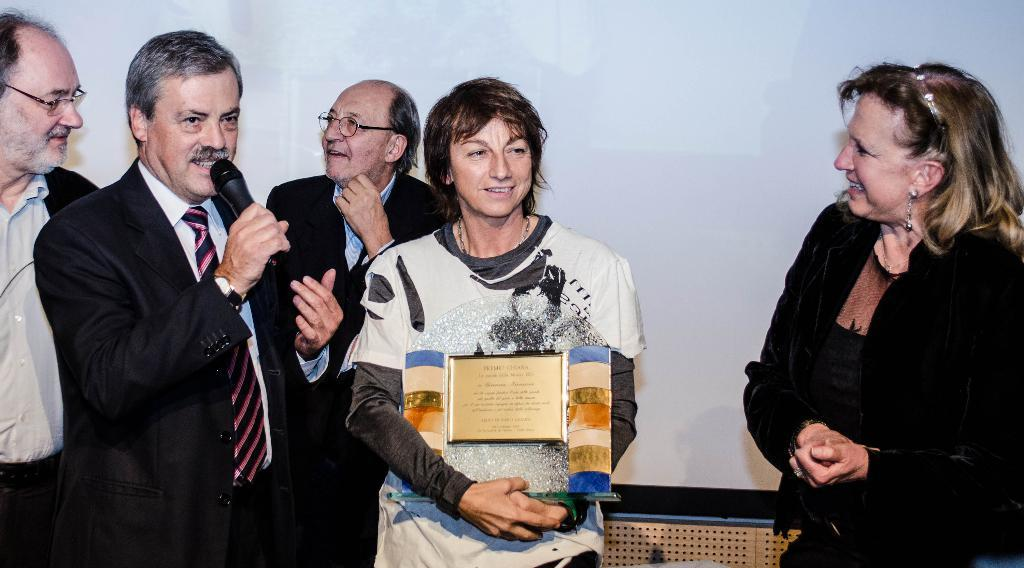What is happening in the image? There are people standing in the image, and one person is holding a microphone and talking. What is the woman holding in the image? The woman is holding a memento. Can you see a mountain in the background of the image? There is no mountain visible in the image. Is there a girl holding a watch in the image? There is no girl or watch present in the image. 